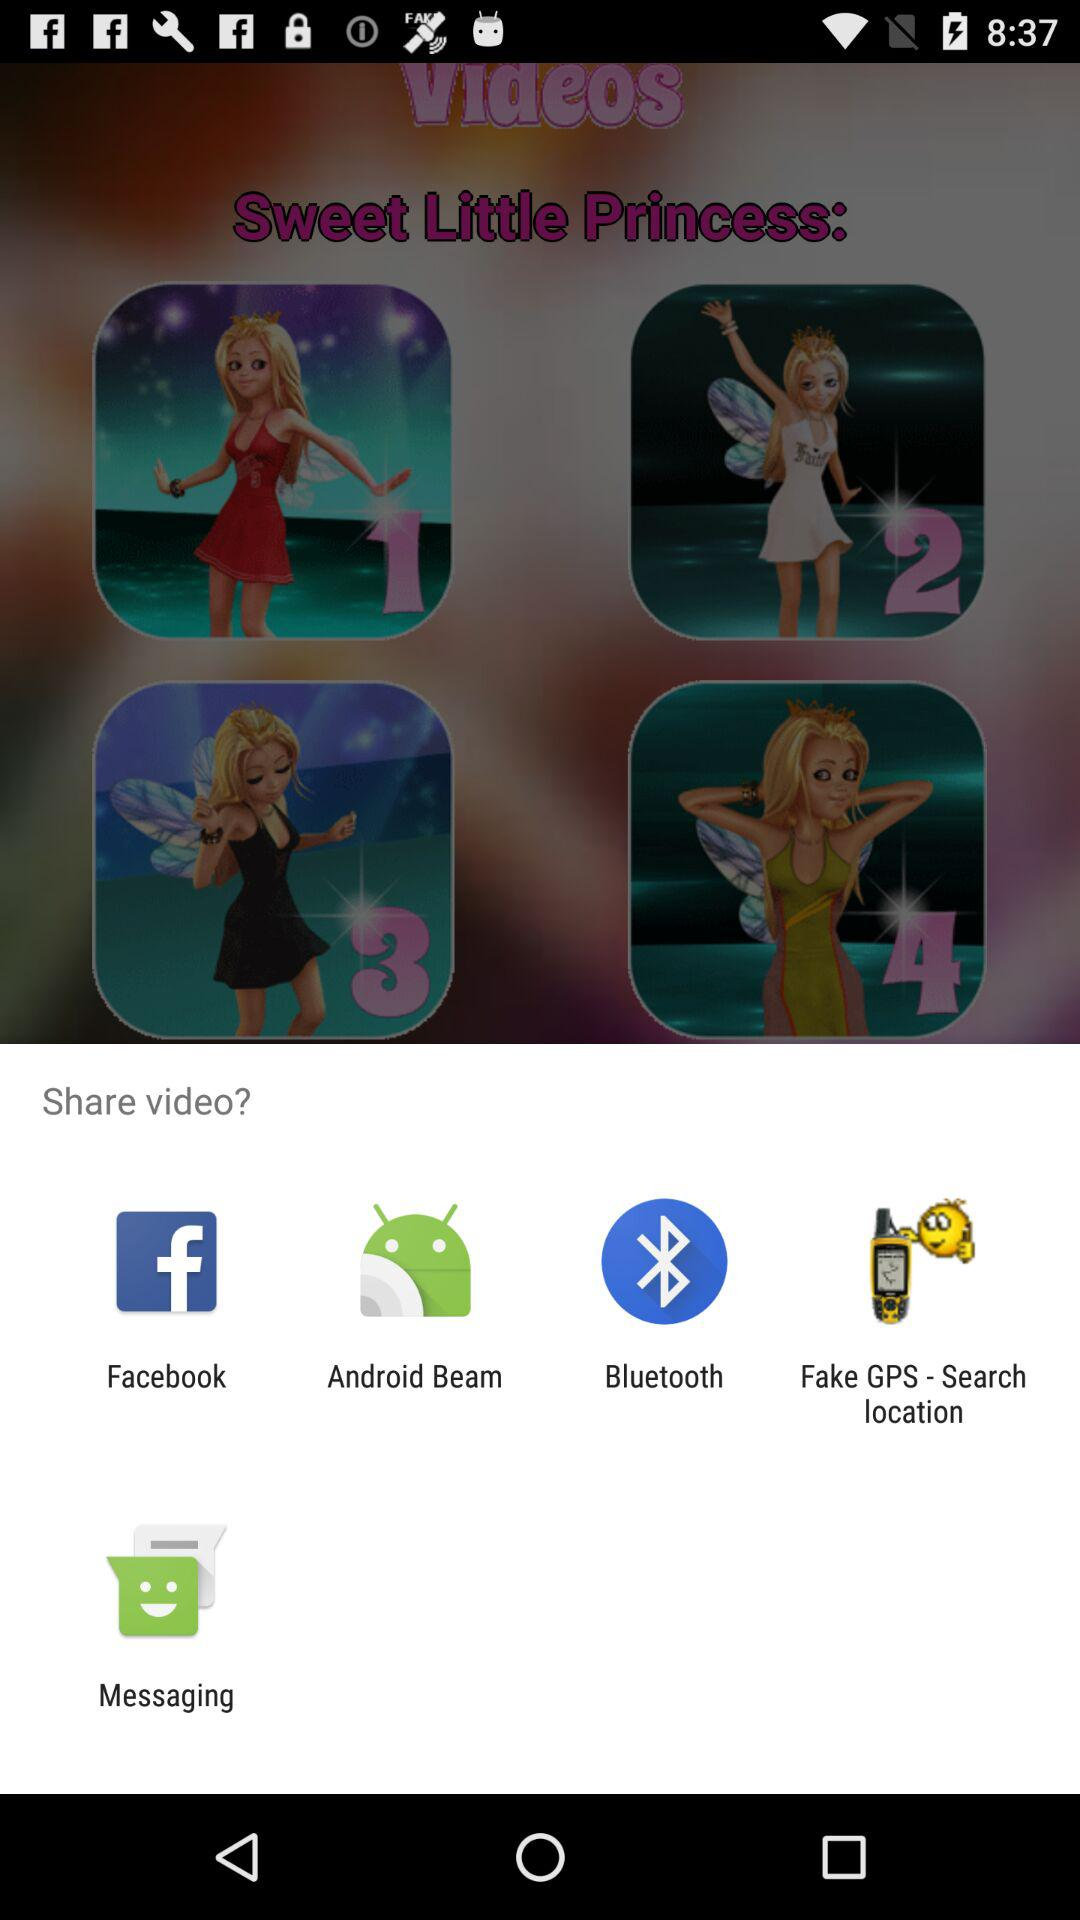How many videos are in this album?
Answer the question using a single word or phrase. 4 